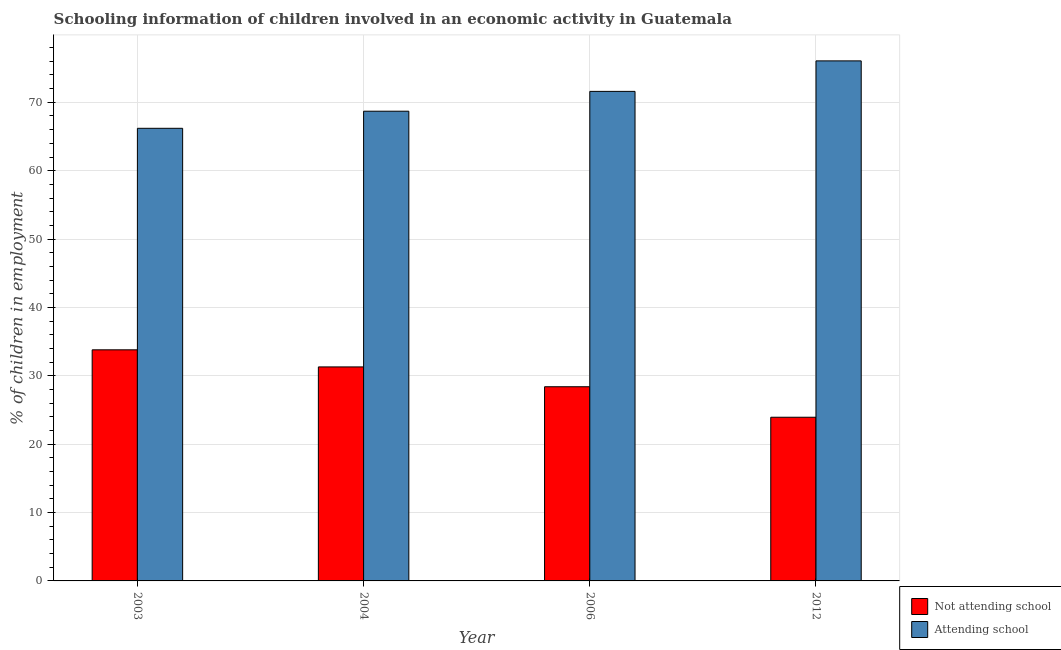Are the number of bars on each tick of the X-axis equal?
Ensure brevity in your answer.  Yes. How many bars are there on the 1st tick from the left?
Your response must be concise. 2. What is the label of the 1st group of bars from the left?
Keep it short and to the point. 2003. What is the percentage of employed children who are attending school in 2006?
Offer a very short reply. 71.6. Across all years, what is the maximum percentage of employed children who are attending school?
Offer a very short reply. 76.06. Across all years, what is the minimum percentage of employed children who are not attending school?
Your response must be concise. 23.94. What is the total percentage of employed children who are attending school in the graph?
Your response must be concise. 282.56. What is the difference between the percentage of employed children who are attending school in 2006 and the percentage of employed children who are not attending school in 2004?
Offer a terse response. 2.9. What is the average percentage of employed children who are attending school per year?
Your response must be concise. 70.64. In the year 2006, what is the difference between the percentage of employed children who are attending school and percentage of employed children who are not attending school?
Your answer should be compact. 0. What is the ratio of the percentage of employed children who are not attending school in 2006 to that in 2012?
Ensure brevity in your answer.  1.19. Is the percentage of employed children who are attending school in 2003 less than that in 2004?
Your answer should be very brief. Yes. Is the difference between the percentage of employed children who are attending school in 2006 and 2012 greater than the difference between the percentage of employed children who are not attending school in 2006 and 2012?
Your answer should be very brief. No. What is the difference between the highest and the second highest percentage of employed children who are attending school?
Offer a terse response. 4.46. What is the difference between the highest and the lowest percentage of employed children who are attending school?
Offer a very short reply. 9.86. In how many years, is the percentage of employed children who are attending school greater than the average percentage of employed children who are attending school taken over all years?
Offer a terse response. 2. What does the 2nd bar from the left in 2006 represents?
Make the answer very short. Attending school. What does the 2nd bar from the right in 2006 represents?
Offer a very short reply. Not attending school. Are all the bars in the graph horizontal?
Your answer should be compact. No. What is the difference between two consecutive major ticks on the Y-axis?
Ensure brevity in your answer.  10. Does the graph contain any zero values?
Offer a terse response. No. Does the graph contain grids?
Ensure brevity in your answer.  Yes. Where does the legend appear in the graph?
Give a very brief answer. Bottom right. How many legend labels are there?
Offer a terse response. 2. How are the legend labels stacked?
Your response must be concise. Vertical. What is the title of the graph?
Keep it short and to the point. Schooling information of children involved in an economic activity in Guatemala. What is the label or title of the X-axis?
Provide a succinct answer. Year. What is the label or title of the Y-axis?
Your answer should be compact. % of children in employment. What is the % of children in employment in Not attending school in 2003?
Provide a succinct answer. 33.8. What is the % of children in employment of Attending school in 2003?
Make the answer very short. 66.2. What is the % of children in employment of Not attending school in 2004?
Your response must be concise. 31.3. What is the % of children in employment of Attending school in 2004?
Make the answer very short. 68.7. What is the % of children in employment in Not attending school in 2006?
Your answer should be compact. 28.4. What is the % of children in employment of Attending school in 2006?
Your response must be concise. 71.6. What is the % of children in employment of Not attending school in 2012?
Your answer should be compact. 23.94. What is the % of children in employment in Attending school in 2012?
Your answer should be compact. 76.06. Across all years, what is the maximum % of children in employment in Not attending school?
Provide a short and direct response. 33.8. Across all years, what is the maximum % of children in employment of Attending school?
Provide a succinct answer. 76.06. Across all years, what is the minimum % of children in employment of Not attending school?
Provide a succinct answer. 23.94. Across all years, what is the minimum % of children in employment of Attending school?
Provide a short and direct response. 66.2. What is the total % of children in employment in Not attending school in the graph?
Your answer should be compact. 117.44. What is the total % of children in employment of Attending school in the graph?
Provide a succinct answer. 282.56. What is the difference between the % of children in employment in Not attending school in 2003 and that in 2004?
Your answer should be very brief. 2.5. What is the difference between the % of children in employment of Not attending school in 2003 and that in 2012?
Offer a terse response. 9.86. What is the difference between the % of children in employment of Attending school in 2003 and that in 2012?
Keep it short and to the point. -9.86. What is the difference between the % of children in employment of Not attending school in 2004 and that in 2012?
Keep it short and to the point. 7.36. What is the difference between the % of children in employment of Attending school in 2004 and that in 2012?
Give a very brief answer. -7.36. What is the difference between the % of children in employment in Not attending school in 2006 and that in 2012?
Make the answer very short. 4.46. What is the difference between the % of children in employment of Attending school in 2006 and that in 2012?
Your answer should be compact. -4.46. What is the difference between the % of children in employment of Not attending school in 2003 and the % of children in employment of Attending school in 2004?
Offer a very short reply. -34.9. What is the difference between the % of children in employment in Not attending school in 2003 and the % of children in employment in Attending school in 2006?
Ensure brevity in your answer.  -37.8. What is the difference between the % of children in employment of Not attending school in 2003 and the % of children in employment of Attending school in 2012?
Provide a short and direct response. -42.26. What is the difference between the % of children in employment of Not attending school in 2004 and the % of children in employment of Attending school in 2006?
Your response must be concise. -40.3. What is the difference between the % of children in employment in Not attending school in 2004 and the % of children in employment in Attending school in 2012?
Ensure brevity in your answer.  -44.76. What is the difference between the % of children in employment of Not attending school in 2006 and the % of children in employment of Attending school in 2012?
Provide a succinct answer. -47.66. What is the average % of children in employment of Not attending school per year?
Offer a terse response. 29.36. What is the average % of children in employment of Attending school per year?
Offer a very short reply. 70.64. In the year 2003, what is the difference between the % of children in employment of Not attending school and % of children in employment of Attending school?
Make the answer very short. -32.4. In the year 2004, what is the difference between the % of children in employment in Not attending school and % of children in employment in Attending school?
Your answer should be compact. -37.4. In the year 2006, what is the difference between the % of children in employment in Not attending school and % of children in employment in Attending school?
Your answer should be very brief. -43.2. In the year 2012, what is the difference between the % of children in employment in Not attending school and % of children in employment in Attending school?
Provide a short and direct response. -52.12. What is the ratio of the % of children in employment in Not attending school in 2003 to that in 2004?
Your response must be concise. 1.08. What is the ratio of the % of children in employment of Attending school in 2003 to that in 2004?
Give a very brief answer. 0.96. What is the ratio of the % of children in employment in Not attending school in 2003 to that in 2006?
Your answer should be compact. 1.19. What is the ratio of the % of children in employment in Attending school in 2003 to that in 2006?
Provide a succinct answer. 0.92. What is the ratio of the % of children in employment in Not attending school in 2003 to that in 2012?
Your answer should be compact. 1.41. What is the ratio of the % of children in employment in Attending school in 2003 to that in 2012?
Provide a short and direct response. 0.87. What is the ratio of the % of children in employment in Not attending school in 2004 to that in 2006?
Make the answer very short. 1.1. What is the ratio of the % of children in employment of Attending school in 2004 to that in 2006?
Ensure brevity in your answer.  0.96. What is the ratio of the % of children in employment in Not attending school in 2004 to that in 2012?
Your response must be concise. 1.31. What is the ratio of the % of children in employment in Attending school in 2004 to that in 2012?
Your answer should be compact. 0.9. What is the ratio of the % of children in employment in Not attending school in 2006 to that in 2012?
Offer a terse response. 1.19. What is the ratio of the % of children in employment of Attending school in 2006 to that in 2012?
Offer a very short reply. 0.94. What is the difference between the highest and the second highest % of children in employment in Attending school?
Your answer should be compact. 4.46. What is the difference between the highest and the lowest % of children in employment in Not attending school?
Offer a very short reply. 9.86. What is the difference between the highest and the lowest % of children in employment of Attending school?
Offer a very short reply. 9.86. 